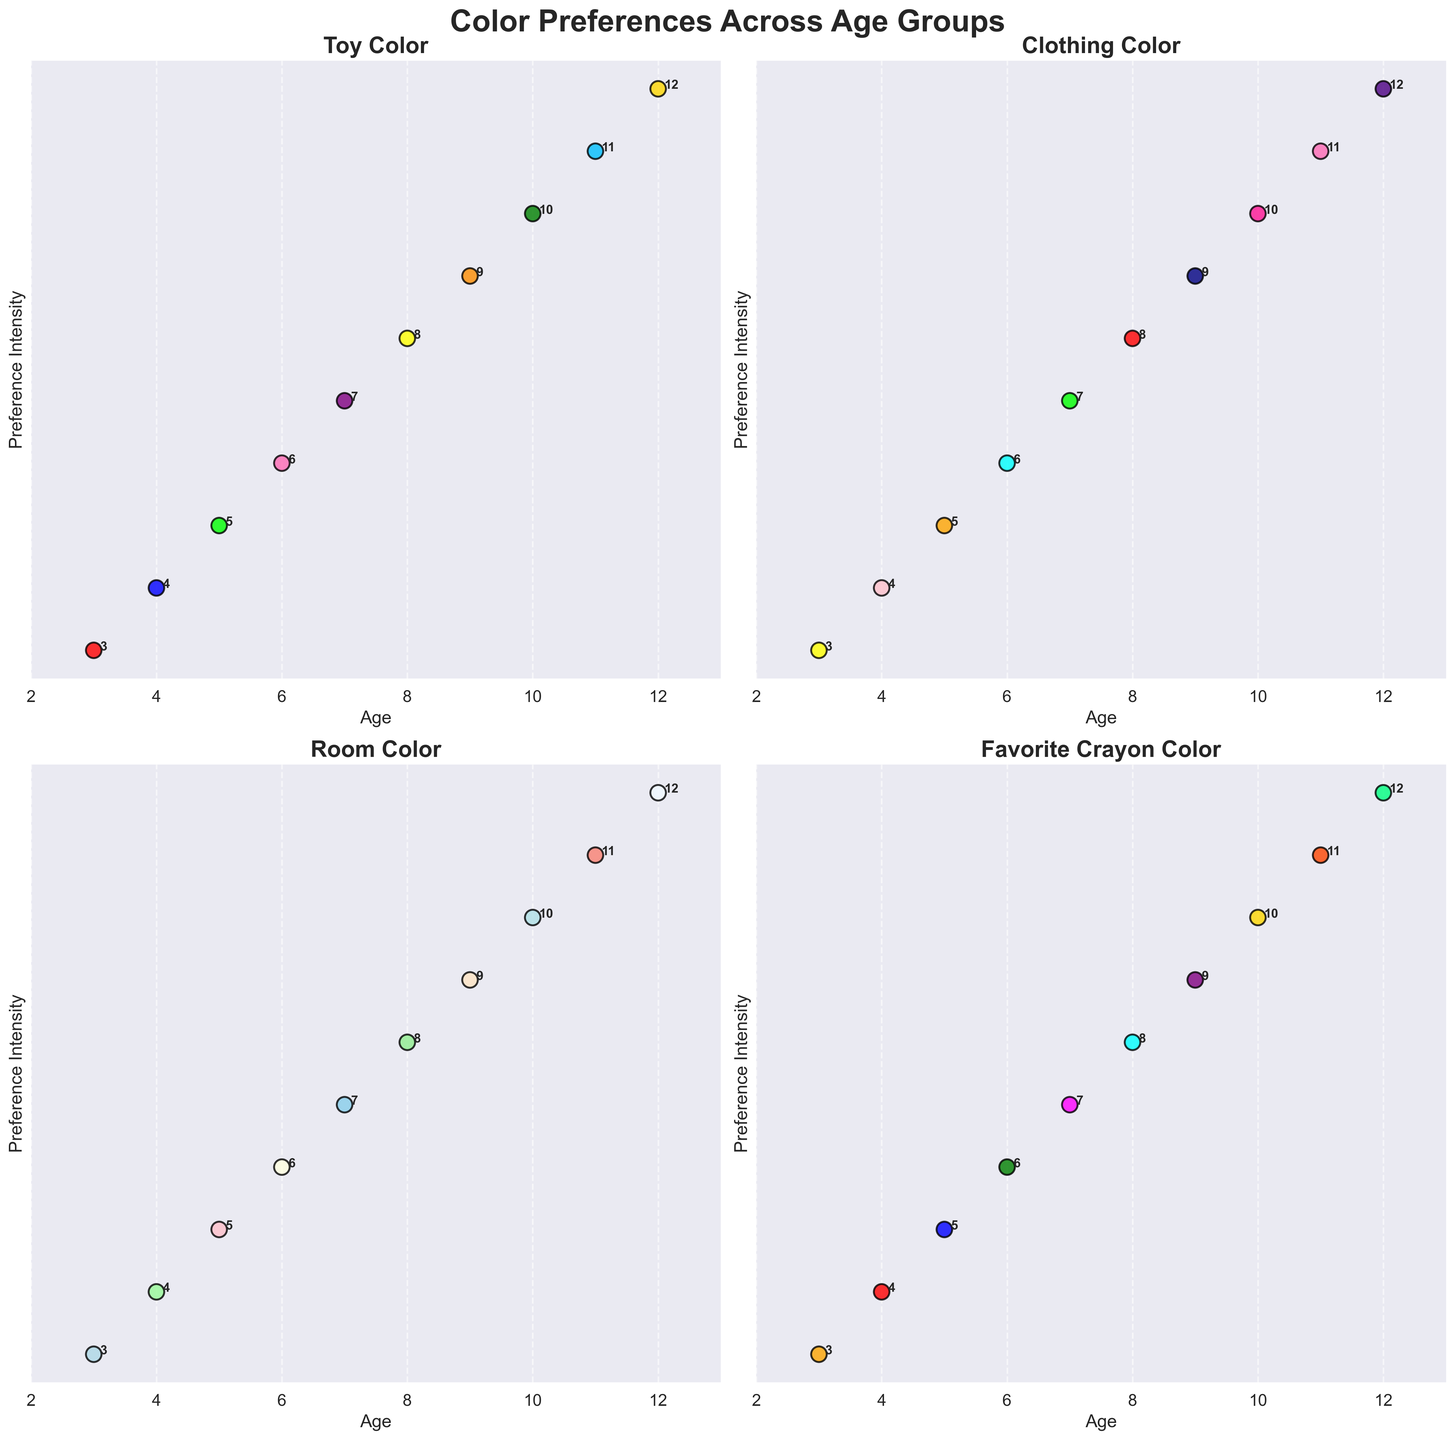what age group has the most diverse color preferences for their room colors? To determine this, we need to visually compare the variety of colors across different ages in the 'Room Color' subplot. The age group that shows the most different shades can be inferred to have the most diverse color preferences.
Answer: Age 3 (bright red, yellow, light blue, and orange colors) Which age group prefers green shades in their toy color? In the 'Toy Color' subplot, look for data points that are in various shades of green. Compare the ages listed alongside those points to identify the age group preferences.
Answer: Age 5 and Age 10 Are the favorite crayon colors more uniform in color preference compared to toy colors? Compare the color distribution in the 'Favorite Crayon Color' subplot with the 'Toy Color' subplot. If the crayon colors are more similar across ages than the toy colors, they are more uniform. The 'Favorite Crayon Color' seems to have more consistently bright colors across ages compared to the more varied 'Toy Color'.
Answer: Yes Which age group shows a transition from preferring vibrant toy colors to more neutral room colors? Observe the 'Toy Color' and 'Room Color' subplots and identify the age groups where a shift from bright toy colors (e.g., bright red, yellow, blue) to more muted room colors (e.g., light green, beige) occurs.
Answer: Age 9 Between ages 4 and 7, which age group prefers blue shades for their clothing? In the 'Clothing Color' subplot, identify data points representing shades of blue and note their associated ages between 4 and 7. Compare these ages to determine which group has a preference for blue clothing.
Answer: Age 4 (light pink and blue) How does the color preference for toy colors change from age 3 to age 12? Track the data points for toy colors from the 'Toy Color' subplot starting from age 3 to age 12. Observe how the color transitions; note any patterns such as moving from brighter to darker colors or any specific color trends.
Answer: It transitions from bright colors (red, blue, green) to more pastel and mixed colors (peach, green, blue, gold) Which age group shows the most color uniformity in their favorite crayon colors? Examine the 'Favorite Crayon Color' subplot for data points that appear very similar across different ages. Identify the age group with the least variation in color preference.
Answer: Age 8 (blue and white) Compare the room color preferences of age 6 and age 10. Which group prefers lighter shades? Investigate the 'Room Color' subplot for data points representing ages 6 and 10. Compare the shades directly by determining which age group has points that appear lighter (closer to white/light shades).
Answer: Age 6 (cream colors) What is the common clothing color preference at age 8? Look at the data point for 'Clothing Color' at age 8 in the subplot. Analyze the color to identify its characteristics.
Answer: Red and dark blue Identify the dominant color for toys at age 5. What about at age 9? Check the 'Toy Color' subplot, locate the points for ages 5 and 9, and identify the dominant colors representing those ages.
Answer: Age 5: Green, Age 9: Orange 